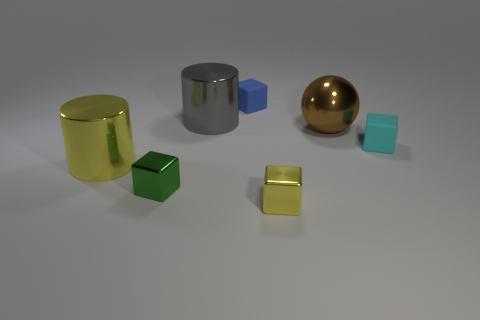Subtract 1 cubes. How many cubes are left? 3 Add 1 blue cylinders. How many objects exist? 8 Subtract all cylinders. How many objects are left? 5 Add 5 tiny yellow shiny blocks. How many tiny yellow shiny blocks are left? 6 Add 5 tiny metal cubes. How many tiny metal cubes exist? 7 Subtract 0 purple blocks. How many objects are left? 7 Subtract all tiny blue cylinders. Subtract all large gray metallic cylinders. How many objects are left? 6 